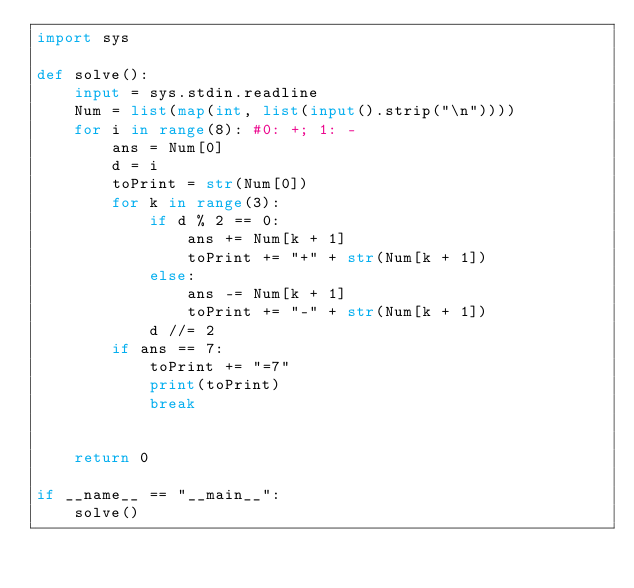Convert code to text. <code><loc_0><loc_0><loc_500><loc_500><_Python_>import sys

def solve():
    input = sys.stdin.readline
    Num = list(map(int, list(input().strip("\n"))))
    for i in range(8): #0: +; 1: -
        ans = Num[0]
        d = i
        toPrint = str(Num[0])
        for k in range(3):
            if d % 2 == 0: 
                ans += Num[k + 1]
                toPrint += "+" + str(Num[k + 1])
            else: 
                ans -= Num[k + 1]
                toPrint += "-" + str(Num[k + 1])
            d //= 2
        if ans == 7:
            toPrint += "=7"
            print(toPrint)
            break


    return 0

if __name__ == "__main__":
    solve()</code> 